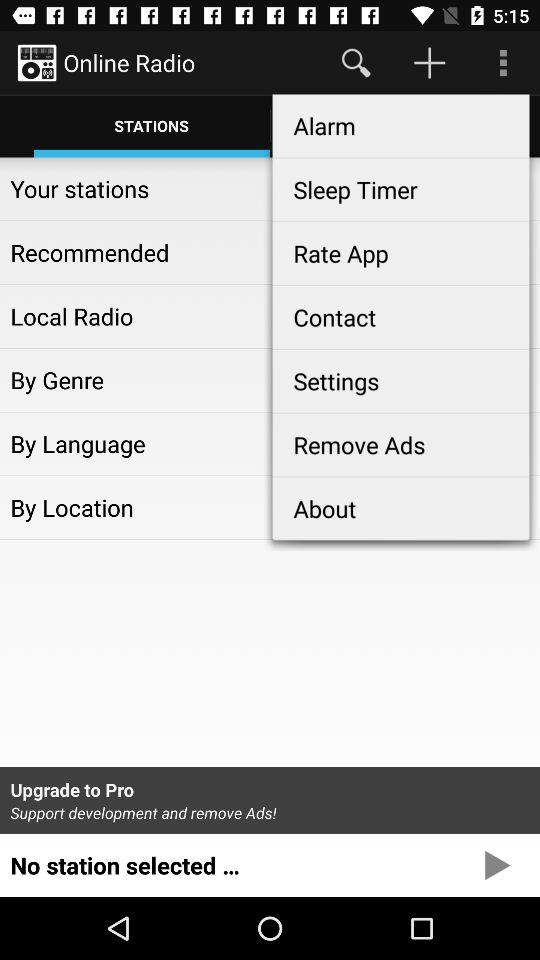What is the name of the application? The application name is Online Radio. 